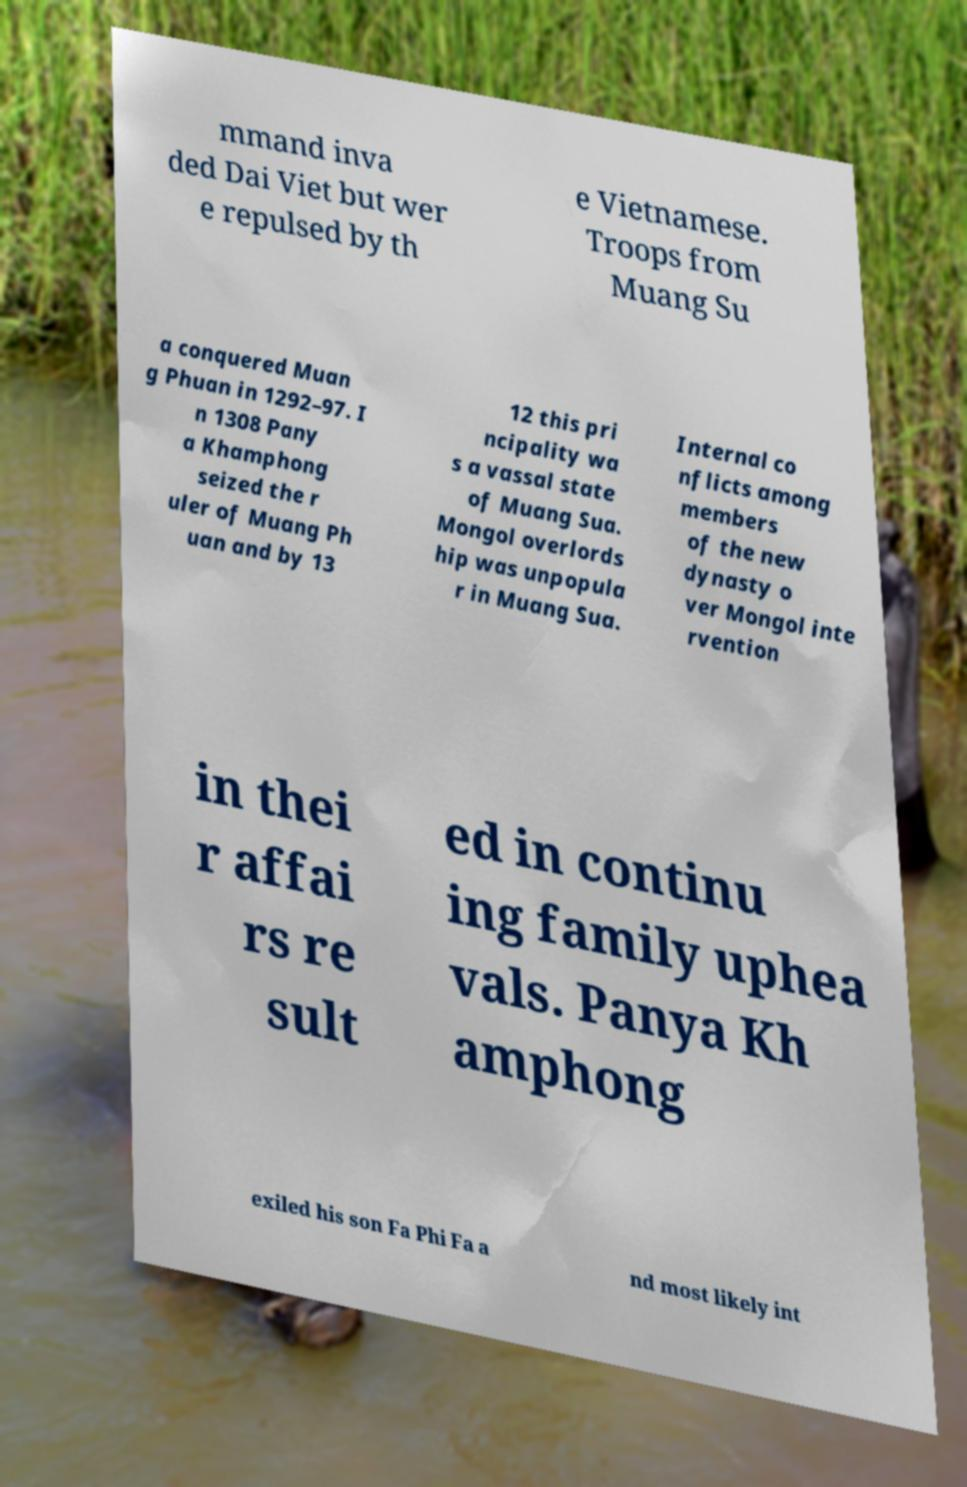Can you read and provide the text displayed in the image?This photo seems to have some interesting text. Can you extract and type it out for me? mmand inva ded Dai Viet but wer e repulsed by th e Vietnamese. Troops from Muang Su a conquered Muan g Phuan in 1292–97. I n 1308 Pany a Khamphong seized the r uler of Muang Ph uan and by 13 12 this pri ncipality wa s a vassal state of Muang Sua. Mongol overlords hip was unpopula r in Muang Sua. Internal co nflicts among members of the new dynasty o ver Mongol inte rvention in thei r affai rs re sult ed in continu ing family uphea vals. Panya Kh amphong exiled his son Fa Phi Fa a nd most likely int 